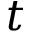<formula> <loc_0><loc_0><loc_500><loc_500>t</formula> 